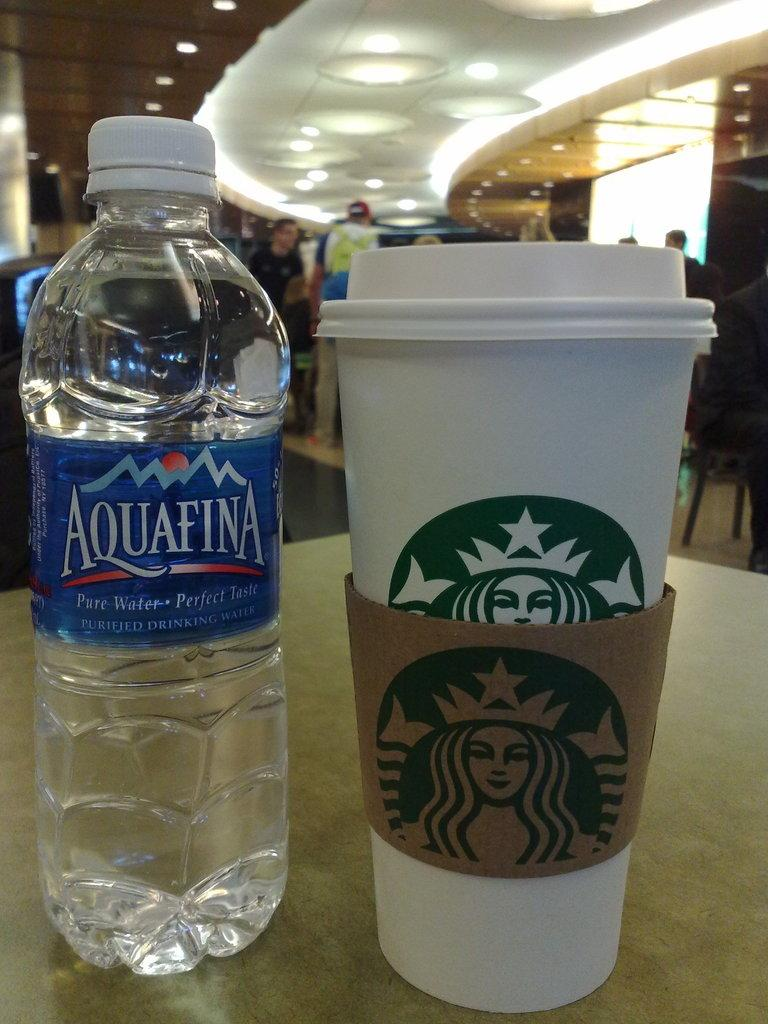<image>
Share a concise interpretation of the image provided. An Aquafina water bottle and a Starbuck cup is sitting on the table 